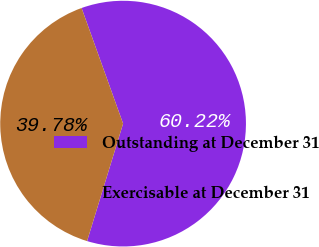Convert chart to OTSL. <chart><loc_0><loc_0><loc_500><loc_500><pie_chart><fcel>Outstanding at December 31<fcel>Exercisable at December 31<nl><fcel>60.22%<fcel>39.78%<nl></chart> 